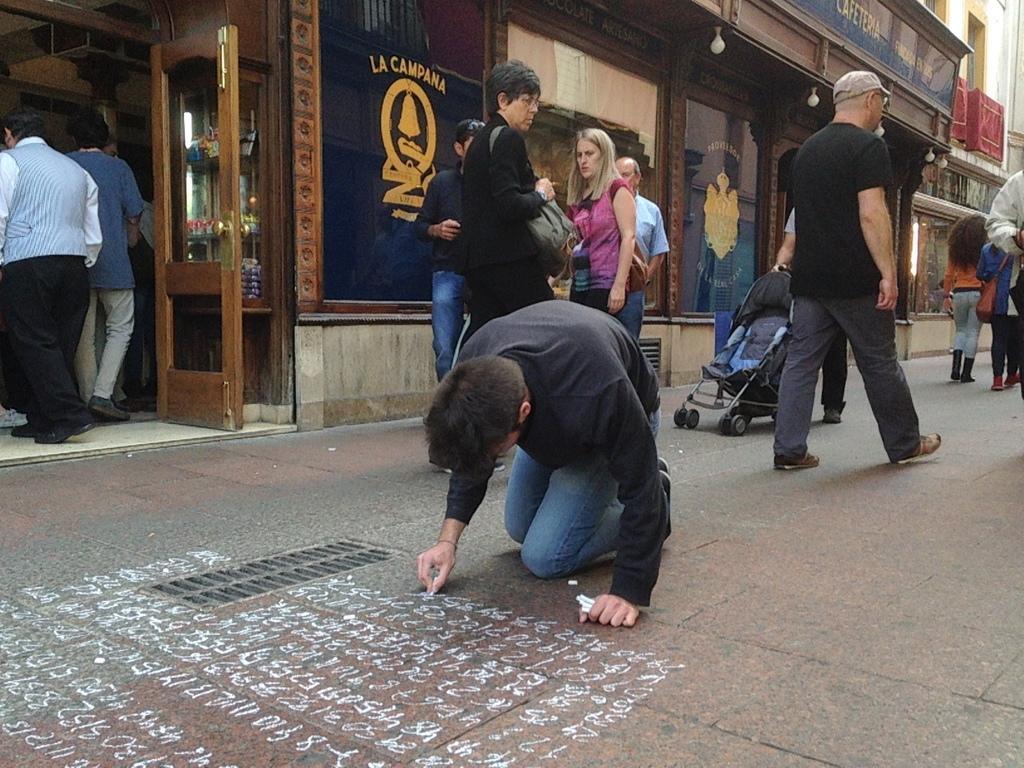Can you describe this image briefly? This picture describes about group of people, few are standing and few are walking, and we can see a man is writing on the floor, in the background we can see few buildings and a baby cart. 